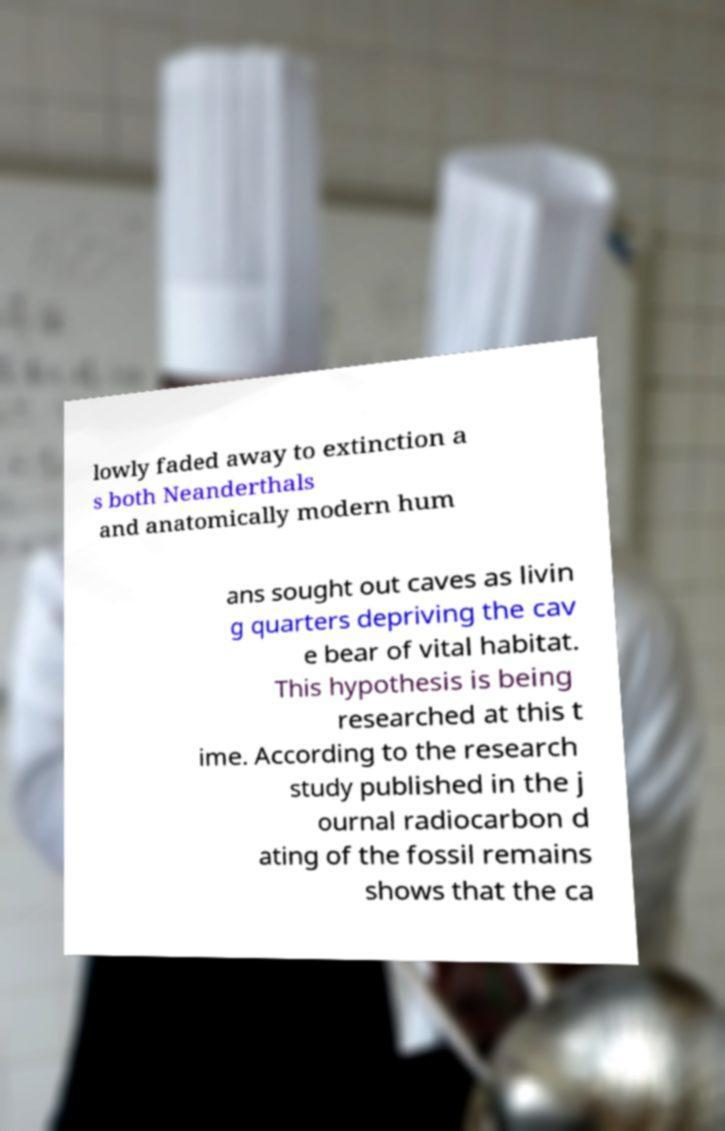Can you accurately transcribe the text from the provided image for me? lowly faded away to extinction a s both Neanderthals and anatomically modern hum ans sought out caves as livin g quarters depriving the cav e bear of vital habitat. This hypothesis is being researched at this t ime. According to the research study published in the j ournal radiocarbon d ating of the fossil remains shows that the ca 